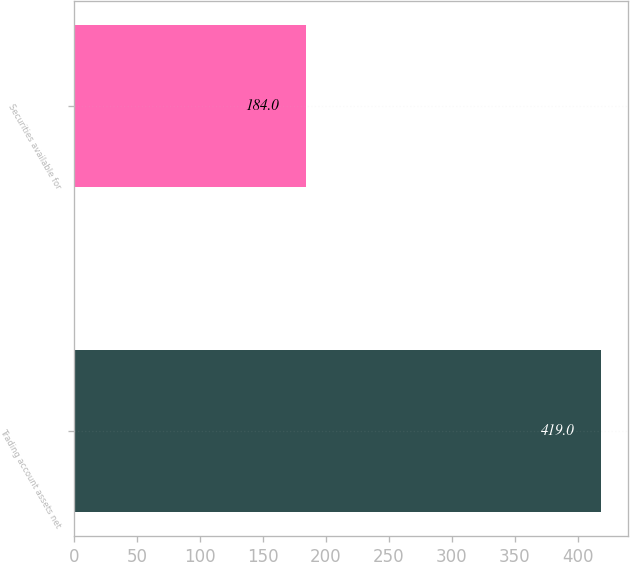Convert chart. <chart><loc_0><loc_0><loc_500><loc_500><bar_chart><fcel>Trading account assets net<fcel>Securities available for<nl><fcel>419<fcel>184<nl></chart> 